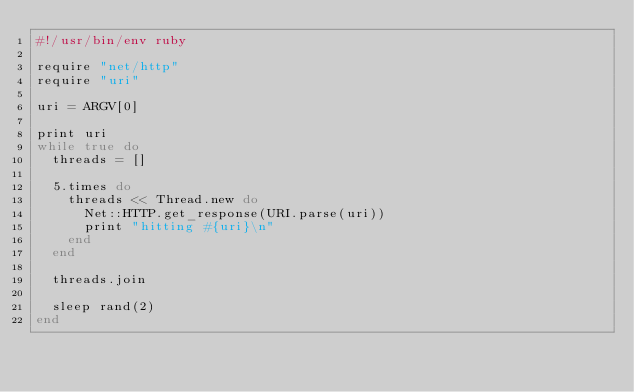Convert code to text. <code><loc_0><loc_0><loc_500><loc_500><_Ruby_>#!/usr/bin/env ruby

require "net/http"
require "uri"

uri = ARGV[0]

print uri
while true do
  threads = []

  5.times do
    threads << Thread.new do
      Net::HTTP.get_response(URI.parse(uri))
      print "hitting #{uri}\n"
    end
  end

  threads.join

  sleep rand(2)
end

</code> 